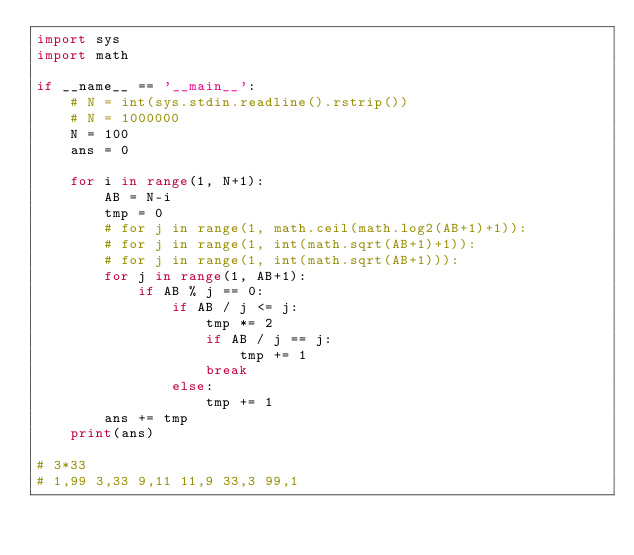Convert code to text. <code><loc_0><loc_0><loc_500><loc_500><_Python_>import sys
import math

if __name__ == '__main__':
    # N = int(sys.stdin.readline().rstrip())
    # N = 1000000
    N = 100
    ans = 0

    for i in range(1, N+1):
        AB = N-i
        tmp = 0
        # for j in range(1, math.ceil(math.log2(AB+1)+1)):
        # for j in range(1, int(math.sqrt(AB+1)+1)):
        # for j in range(1, int(math.sqrt(AB+1))):
        for j in range(1, AB+1):
            if AB % j == 0:
                if AB / j <= j:
                    tmp *= 2
                    if AB / j == j:
                        tmp += 1
                    break
                else:
                    tmp += 1
        ans += tmp
    print(ans)

# 3*33
# 1,99 3,33 9,11 11,9 33,3 99,1</code> 